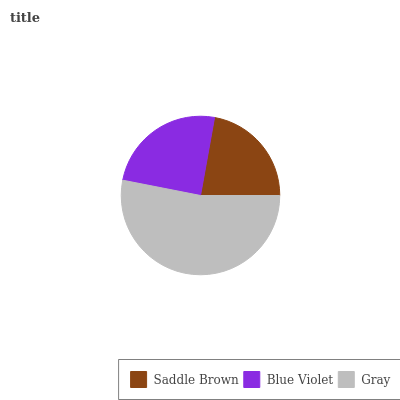Is Saddle Brown the minimum?
Answer yes or no. Yes. Is Gray the maximum?
Answer yes or no. Yes. Is Blue Violet the minimum?
Answer yes or no. No. Is Blue Violet the maximum?
Answer yes or no. No. Is Blue Violet greater than Saddle Brown?
Answer yes or no. Yes. Is Saddle Brown less than Blue Violet?
Answer yes or no. Yes. Is Saddle Brown greater than Blue Violet?
Answer yes or no. No. Is Blue Violet less than Saddle Brown?
Answer yes or no. No. Is Blue Violet the high median?
Answer yes or no. Yes. Is Blue Violet the low median?
Answer yes or no. Yes. Is Gray the high median?
Answer yes or no. No. Is Saddle Brown the low median?
Answer yes or no. No. 